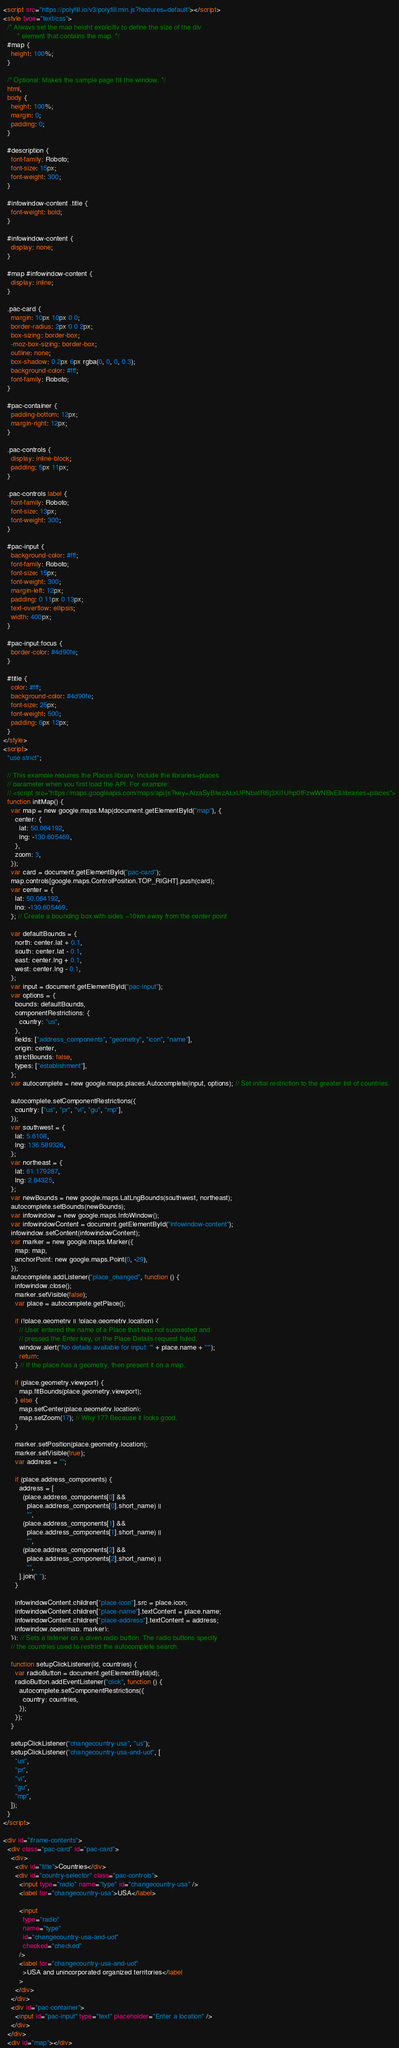Convert code to text. <code><loc_0><loc_0><loc_500><loc_500><_HTML_><script src="https://polyfill.io/v3/polyfill.min.js?features=default"></script>
<style type="text/css">
  /* Always set the map height explicitly to define the size of the div
       * element that contains the map. */
  #map {
    height: 100%;
  }

  /* Optional: Makes the sample page fill the window. */
  html,
  body {
    height: 100%;
    margin: 0;
    padding: 0;
  }

  #description {
    font-family: Roboto;
    font-size: 15px;
    font-weight: 300;
  }

  #infowindow-content .title {
    font-weight: bold;
  }

  #infowindow-content {
    display: none;
  }

  #map #infowindow-content {
    display: inline;
  }

  .pac-card {
    margin: 10px 10px 0 0;
    border-radius: 2px 0 0 2px;
    box-sizing: border-box;
    -moz-box-sizing: border-box;
    outline: none;
    box-shadow: 0 2px 6px rgba(0, 0, 0, 0.3);
    background-color: #fff;
    font-family: Roboto;
  }

  #pac-container {
    padding-bottom: 12px;
    margin-right: 12px;
  }

  .pac-controls {
    display: inline-block;
    padding: 5px 11px;
  }

  .pac-controls label {
    font-family: Roboto;
    font-size: 13px;
    font-weight: 300;
  }

  #pac-input {
    background-color: #fff;
    font-family: Roboto;
    font-size: 15px;
    font-weight: 300;
    margin-left: 12px;
    padding: 0 11px 0 13px;
    text-overflow: ellipsis;
    width: 400px;
  }

  #pac-input:focus {
    border-color: #4d90fe;
  }

  #title {
    color: #fff;
    background-color: #4d90fe;
    font-size: 25px;
    font-weight: 500;
    padding: 6px 12px;
  }
</style>
<script>
  "use strict";

  // This example requires the Places library. Include the libraries=places
  // parameter when you first load the API. For example:
  // <script src="https://maps.googleapis.com/maps/api/js?key=AIzaSyBIwzALxUPNbatRBj3Xi1Uhp0fFzwWNBkE&libraries=places">
  function initMap() {
    var map = new google.maps.Map(document.getElementById("map"), {
      center: {
        lat: 50.064192,
        lng: -130.605469,
      },
      zoom: 3,
    });
    var card = document.getElementById("pac-card");
    map.controls[google.maps.ControlPosition.TOP_RIGHT].push(card);
    var center = {
      lat: 50.064192,
      lng: -130.605469,
    }; // Create a bounding box with sides ~10km away from the center point

    var defaultBounds = {
      north: center.lat + 0.1,
      south: center.lat - 0.1,
      east: center.lng + 0.1,
      west: center.lng - 0.1,
    };
    var input = document.getElementById("pac-input");
    var options = {
      bounds: defaultBounds,
      componentRestrictions: {
        country: "us",
      },
      fields: ["address_components", "geometry", "icon", "name"],
      origin: center,
      strictBounds: false,
      types: ["establishment"],
    };
    var autocomplete = new google.maps.places.Autocomplete(input, options); // Set initial restriction to the greater list of countries.

    autocomplete.setComponentRestrictions({
      country: ["us", "pr", "vi", "gu", "mp"],
    });
    var southwest = {
      lat: 5.6108,
      lng: 136.589326,
    };
    var northeast = {
      lat: 61.179287,
      lng: 2.64325,
    };
    var newBounds = new google.maps.LatLngBounds(southwest, northeast);
    autocomplete.setBounds(newBounds);
    var infowindow = new google.maps.InfoWindow();
    var infowindowContent = document.getElementById("infowindow-content");
    infowindow.setContent(infowindowContent);
    var marker = new google.maps.Marker({
      map: map,
      anchorPoint: new google.maps.Point(0, -29),
    });
    autocomplete.addListener("place_changed", function () {
      infowindow.close();
      marker.setVisible(false);
      var place = autocomplete.getPlace();

      if (!place.geometry || !place.geometry.location) {
        // User entered the name of a Place that was not suggested and
        // pressed the Enter key, or the Place Details request failed.
        window.alert("No details available for input: '" + place.name + "'");
        return;
      } // If the place has a geometry, then present it on a map.

      if (place.geometry.viewport) {
        map.fitBounds(place.geometry.viewport);
      } else {
        map.setCenter(place.geometry.location);
        map.setZoom(17); // Why 17? Because it looks good.
      }

      marker.setPosition(place.geometry.location);
      marker.setVisible(true);
      var address = "";

      if (place.address_components) {
        address = [
          (place.address_components[0] &&
            place.address_components[0].short_name) ||
            "",
          (place.address_components[1] &&
            place.address_components[1].short_name) ||
            "",
          (place.address_components[2] &&
            place.address_components[2].short_name) ||
            "",
        ].join(" ");
      }

      infowindowContent.children["place-icon"].src = place.icon;
      infowindowContent.children["place-name"].textContent = place.name;
      infowindowContent.children["place-address"].textContent = address;
      infowindow.open(map, marker);
    }); // Sets a listener on a given radio button. The radio buttons specify
    // the countries used to restrict the autocomplete search.

    function setupClickListener(id, countries) {
      var radioButton = document.getElementById(id);
      radioButton.addEventListener("click", function () {
        autocomplete.setComponentRestrictions({
          country: countries,
        });
      });
    }

    setupClickListener("changecountry-usa", "us");
    setupClickListener("changecountry-usa-and-uot", [
      "us",
      "pr",
      "vi",
      "gu",
      "mp",
    ]);
  }
</script>

<div id="iframe-contents">
  <div class="pac-card" id="pac-card">
    <div>
      <div id="title">Countries</div>
      <div id="country-selector" class="pac-controls">
        <input type="radio" name="type" id="changecountry-usa" />
        <label for="changecountry-usa">USA</label>

        <input
          type="radio"
          name="type"
          id="changecountry-usa-and-uot"
          checked="checked"
        />
        <label for="changecountry-usa-and-uot"
          >USA and unincorporated organized territories</label
        >
      </div>
    </div>
    <div id="pac-container">
      <input id="pac-input" type="text" placeholder="Enter a location" />
    </div>
  </div>
  <div id="map"></div></code> 